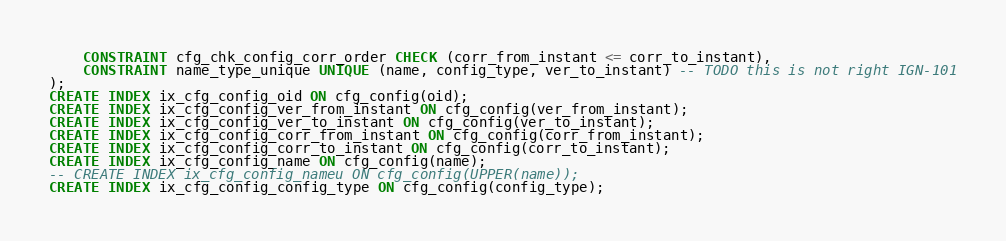Convert code to text. <code><loc_0><loc_0><loc_500><loc_500><_SQL_>    CONSTRAINT cfg_chk_config_corr_order CHECK (corr_from_instant <= corr_to_instant),
    CONSTRAINT name_type_unique UNIQUE (name, config_type, ver_to_instant) -- TODO this is not right IGN-101
);
CREATE INDEX ix_cfg_config_oid ON cfg_config(oid);
CREATE INDEX ix_cfg_config_ver_from_instant ON cfg_config(ver_from_instant);
CREATE INDEX ix_cfg_config_ver_to_instant ON cfg_config(ver_to_instant);
CREATE INDEX ix_cfg_config_corr_from_instant ON cfg_config(corr_from_instant);
CREATE INDEX ix_cfg_config_corr_to_instant ON cfg_config(corr_to_instant);
CREATE INDEX ix_cfg_config_name ON cfg_config(name);
-- CREATE INDEX ix_cfg_config_nameu ON cfg_config(UPPER(name));
CREATE INDEX ix_cfg_config_config_type ON cfg_config(config_type);
</code> 